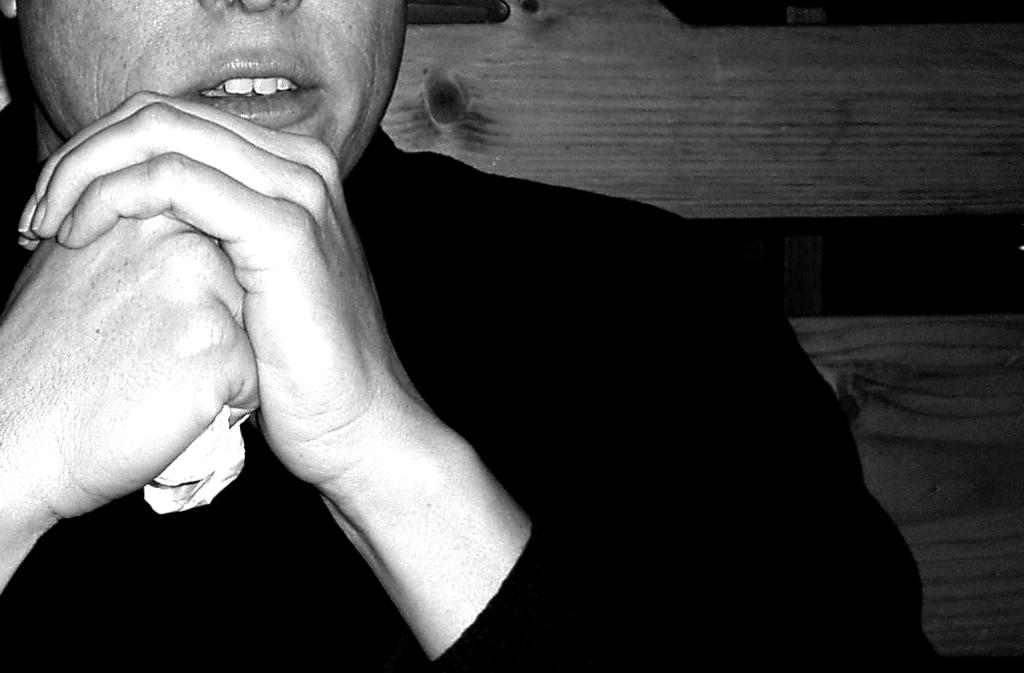What is the color scheme of the image? The image is black and white. What can be seen in the image? There is a person sitting in the image. What type of material can be seen in the background of the image? There are wooden boards in the background of the image. How many copper pots are visible in the image? There are no copper pots present in the image. What type of sorting method is being used by the person in the image? The image does not show any sorting activity, and therefore no sorting method can be observed. 